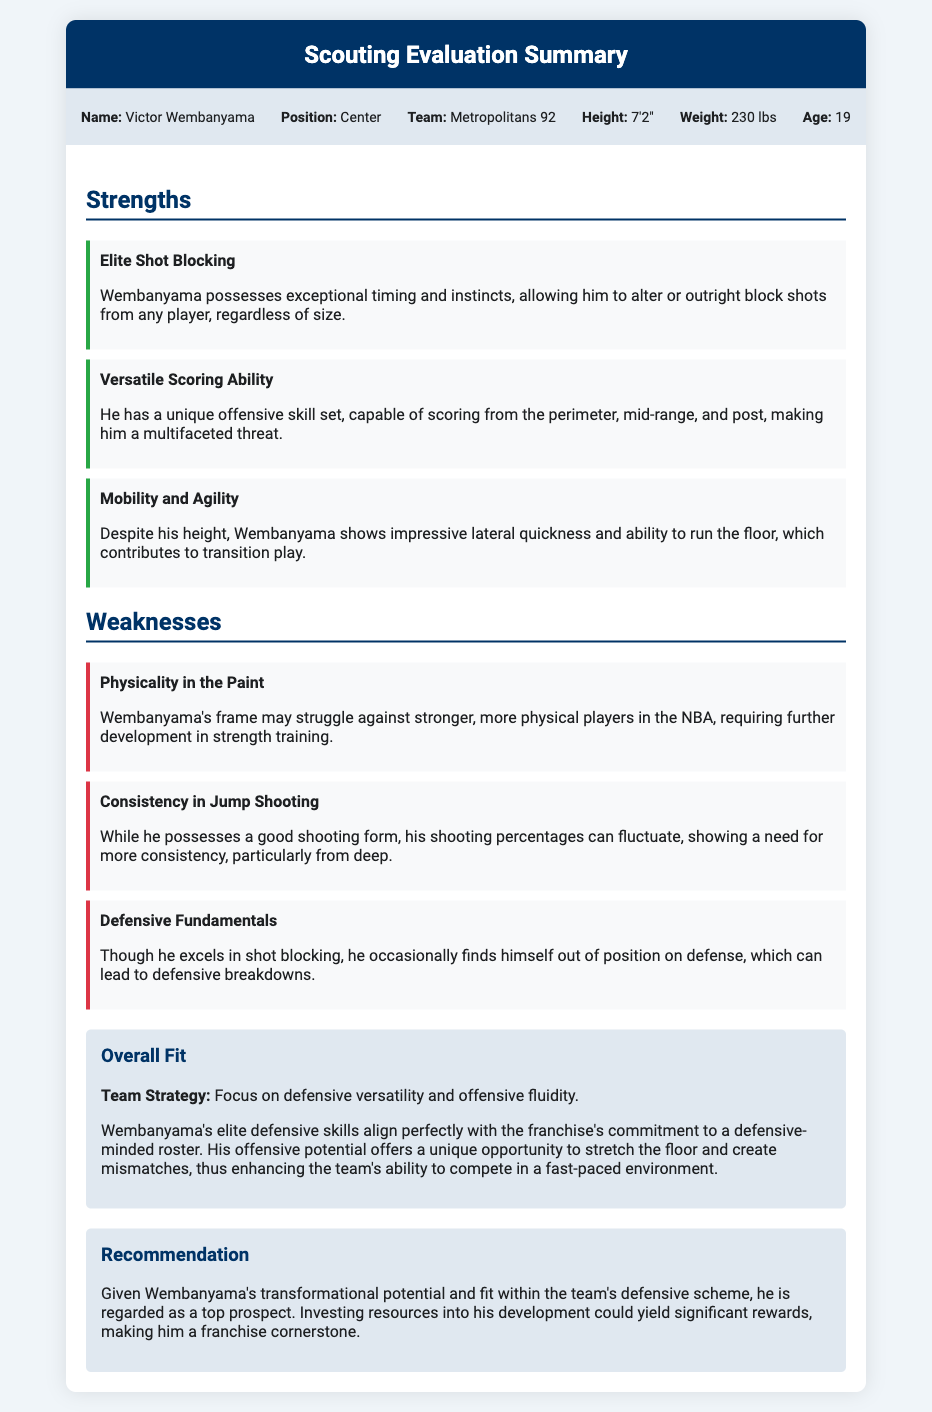What is the name of the prospect? The name of the prospect is provided in the document as Victor Wembanyama.
Answer: Victor Wembanyama What position does Wembanyama play? The document states that Wembanyama plays the position of Center.
Answer: Center How tall is Victor Wembanyama? The height of Wembanyama is given as 7'2".
Answer: 7'2" What is one of Wembanyama's strengths? The document lists multiple strengths, one of which is Elite Shot Blocking, indicating his exceptional skills in this area.
Answer: Elite Shot Blocking What is a reported weakness of Wembanyama? The evaluation mentions several weaknesses; one of them is Physicality in the Paint, indicating a need for improvement in this area.
Answer: Physicality in the Paint What is the team's strategy regarding defense? The document outlines the team's strategy as focusing on defensive versatility and offensive fluidity.
Answer: Defensive versatility and offensive fluidity What does the overall fit say about Wembanyama's defense? The overall fit highlights Wembanyama's elite defensive skills, aligning them with the franchise's commitment to a defensive-minded roster.
Answer: Elite defensive skills What age is Victor Wembanyama? Wembanyama's age is given as 19 years.
Answer: 19 What is the recommendation regarding Wembanyama? The recommendation states that investing resources into his development could yield significant rewards and make him a franchise cornerstone.
Answer: Franchise cornerstone 